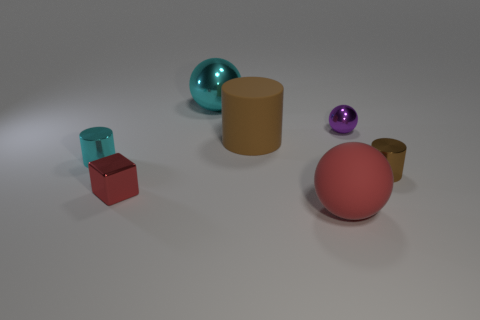Is the number of yellow objects less than the number of big brown objects? Yes, the number of yellow objects, which appears to be just one, is indeed less than the number of big brown objects present in the image, assuming we are considering the two sizable brown cylinders as the 'big brown objects.' It's interesting to note the variety of objects and colors depicted, providing a simple yet visually engaging composition. 